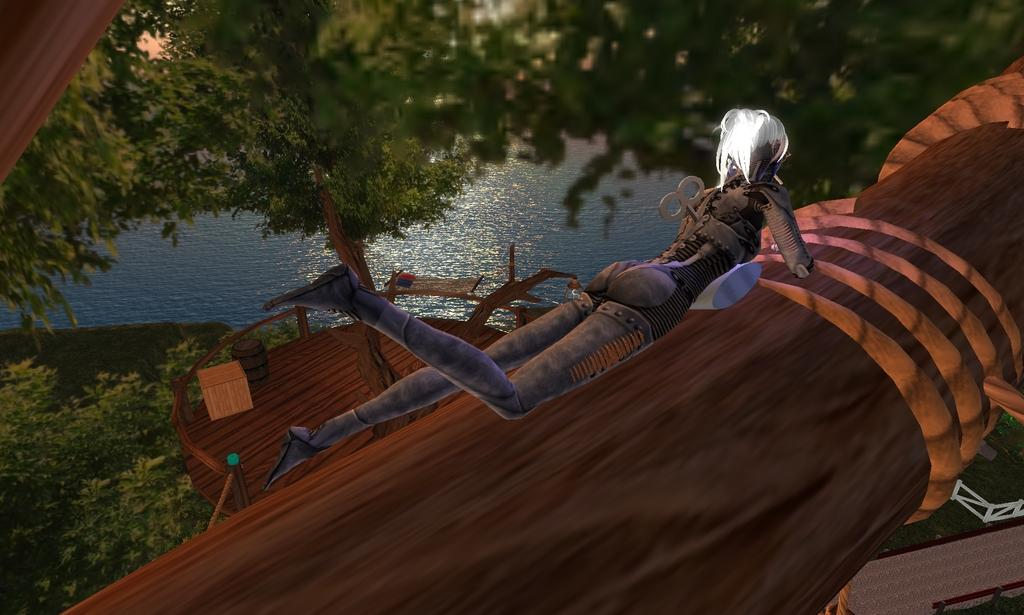What type of image is being described? The image is an animation. What natural elements can be seen in the image? There are trees and water in the image. Are there any human figures present in the image? Yes, there is a woman in the image. What is the nationality of the cap worn by the woman in the image? There is no cap worn by the woman in the image, so it is not possible to determine her nationality based on a cap. 